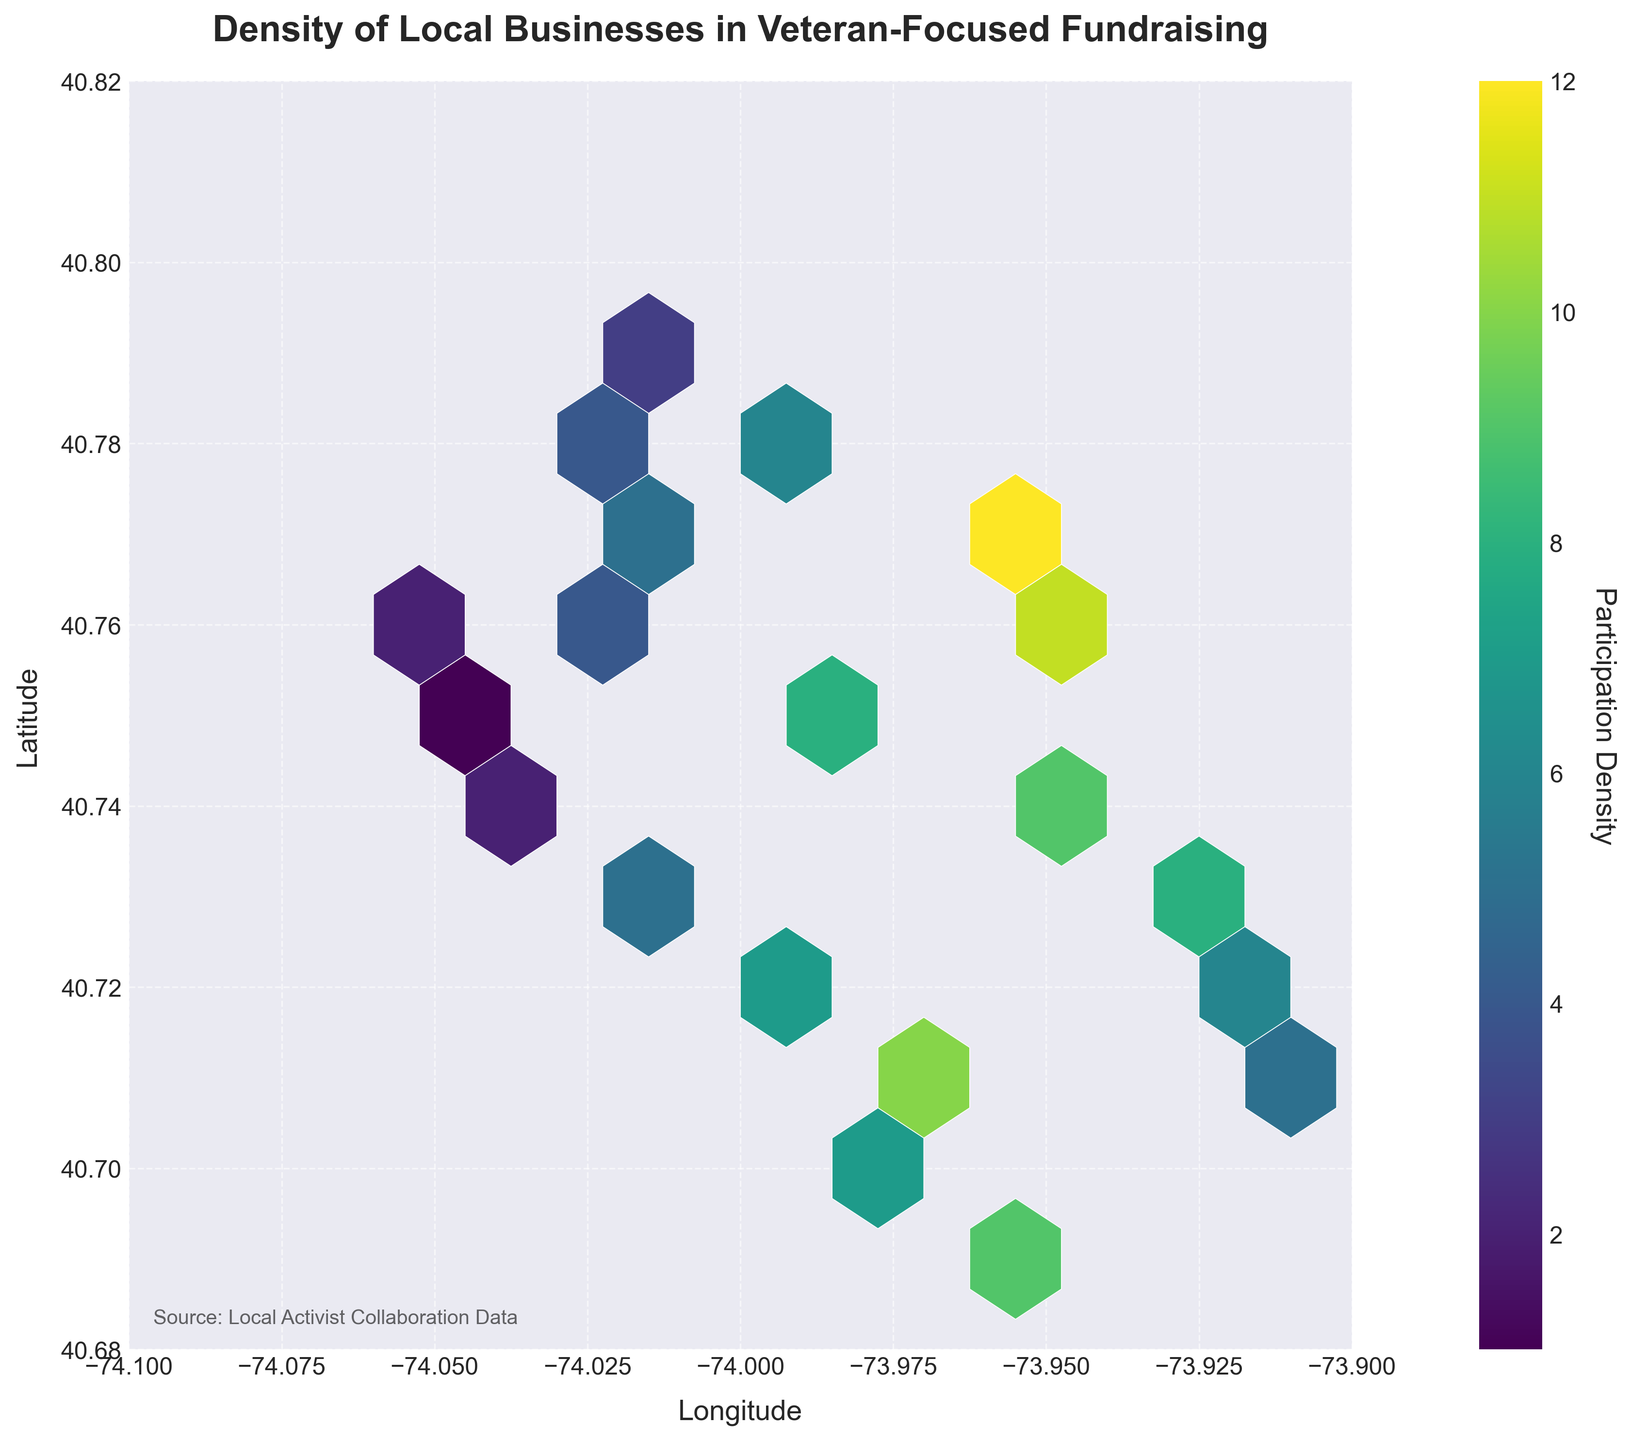How many hexagonal bins are shown in the plot? Count the number of hexagonal bins displayed.
Answer: 10 What are the ranges of the longitude and latitude axes? The x-axis represents longitude and ranges from -74.1 to -73.9, and the y-axis represents latitude and ranges from 40.68 to 40.82.
Answer: Longitude: -74.1 to -73.9, Latitude: 40.68 to 40.82 What does the color bar on the plot represent? The color bar indicates the density of local businesses participating in veteran-focused fundraising initiatives.
Answer: Participation Density Which area has the highest participation density? Look for the bin with the darkest color, which represents the highest density according to the given colormap 'viridis'.
Answer: Area near (-73.96, 40.77) How many hexagonal bins have a participation density of 5? Identify and count the hexagonal bins with the color corresponding to a density value of 5.
Answer: 4 Which coordinates have the lowest participation density? Find the coordinates that fall into the bin with the lightest color, as this represents the lowest density on the color bar.
Answer: Around (-74.05, 40.75) What is the main title of the plot? The main title can be found at the top of the plot.
Answer: Density of Local Businesses in Veteran-Focused Fundraising Compare the density between the areas near coordinates (-74.01, 40.73) and (-74.03, 40.76). Which has higher participation? Identify the color/density of the bins near these coordinates and compare. The darker color indicates a higher density.
Answer: (-74.01, 40.73) What information does the text at the bottom of the plot provide? Read the text located at the bottom of the plot.
Answer: Source: Local Activist Collaboration Data What is the average participation density value, and how is it shown in the plot? Calculate the average of all given density values, and understand how the plot represents these values with color gradients. Average density = (Sum of densities) / (Number of data points) = (8 + 5 + 12 + 7 + 4 + 9 + 6 + 10 + 3 + 11 + 2 + 8 + 5 + 7 + 1 + 6 + 4 + 9 + 2 + 5) / 20 = 5.9
Answer: 5.9 